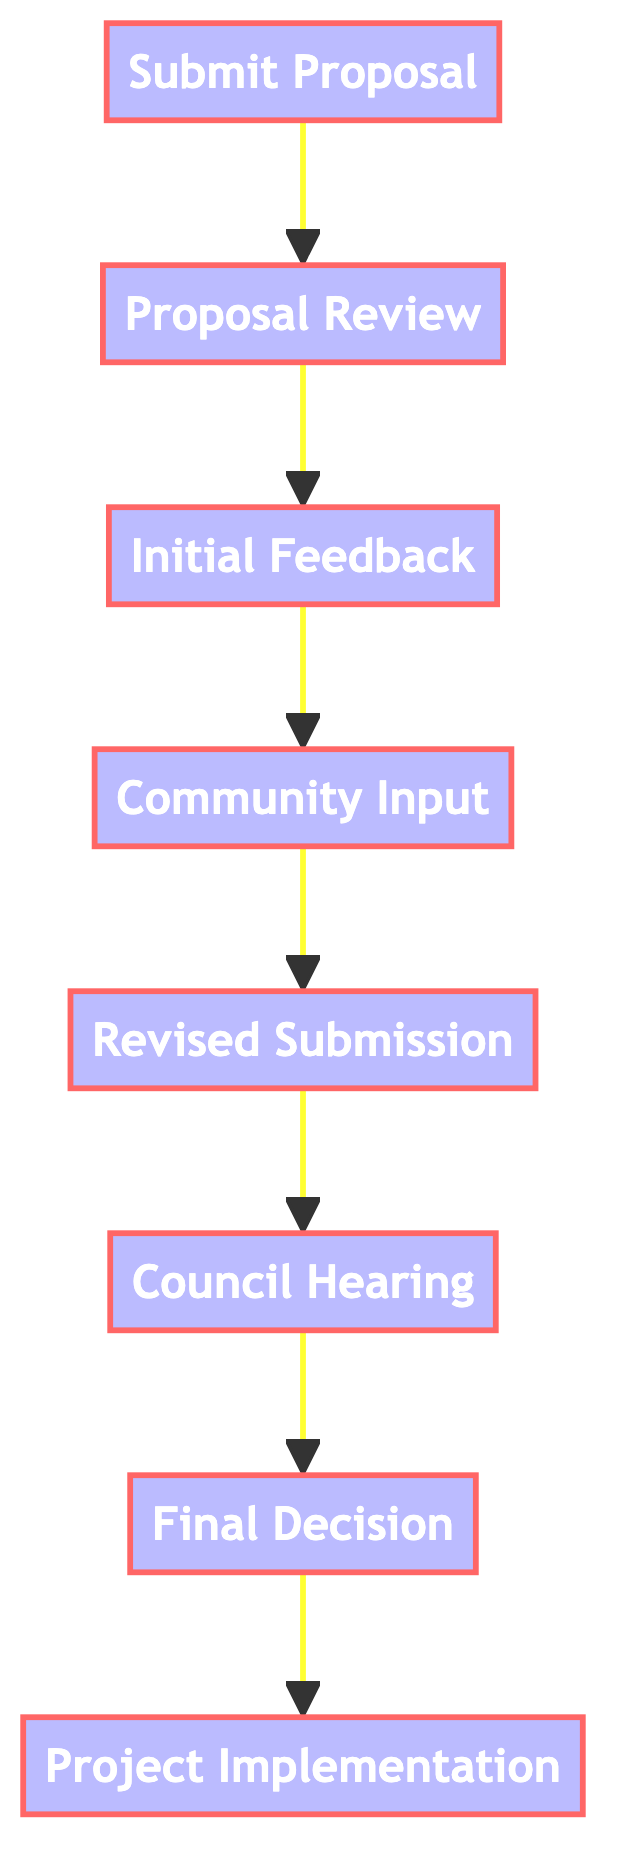What is the first step in the proposal process? The first step in the proposal process is "Submit Proposal". It is the starting point of the flowchart, indicating that submitting the proposal is necessary before any further actions can take place.
Answer: Submit Proposal How many total steps are involved in the process? The flowchart includes eight steps: Submit Proposal, Proposal Review, Initial Feedback, Community Input, Revised Submission, Council Hearing, Final Decision, and Project Implementation. Counting these nodes gives us the total.
Answer: Eight What is the last step in the proposal process? The last step is "Project Implementation". It follows all the previous steps, indicating that once a project proposal is approved, the implementation phase begins.
Answer: Project Implementation Which step directly follows the "Community Input" step? The step that follows "Community Input" is "Revised Submission". This shows that after gathering community support and input, the proposal is revised and submitted again.
Answer: Revised Submission What must happen before the "Council Hearing"? Before the "Council Hearing", the "Revised Submission" must occur. This indicates that the proposal needs to be revised based on feedback and input before it can be presented at the hearing.
Answer: Revised Submission What is required to transition from "Initial Feedback" to "Community Input"? The transition from "Initial Feedback" to "Community Input" is dependent on receiving initial feedback from the City Council. This indicates that feedback must come first before community engagement can take place.
Answer: Initial Feedback Which two steps are dependent on the "Proposal Review"? The two steps that depend on "Proposal Review" are "Initial Feedback" and "Community Input". This indicates that both feedback from the Council and community engagement come after the review of the proposal.
Answer: Initial Feedback and Community Input How many steps occur after the "Final Decision" step? There are no steps that occur after the "Final Decision". Once the decision is made, the process culminates in the "Project Implementation", which is the final step in this flowchart.
Answer: Zero 